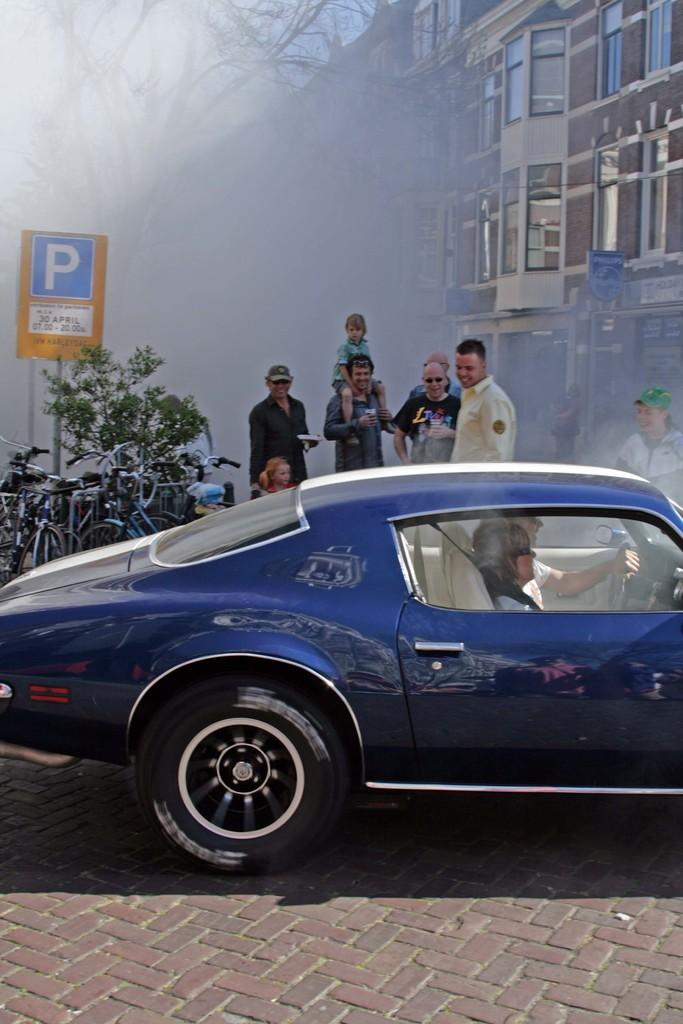What is on the road in the image? There is a vehicle on the road in the image. What else can be seen on the road besides the vehicle? There are people standing on the road in the image. What type of transportation is also visible in the image? There are bicycles visible in the image. What is present in the image that is not a vehicle or bicycle? There is a plant in the image. What type of structure can be seen in the image? There is a building in the image. What object is present in the image that is not a vehicle, bicycle, plant, or building? There is a board in the image. What is the partner doing in the image? There is no mention of a partner in the image; it only features a vehicle, people, bicycles, a plant, a building, and a board. How can the back of the vehicle be used in the image? The back of the vehicle is not mentioned in the image, so it cannot be determined how it might be used. 